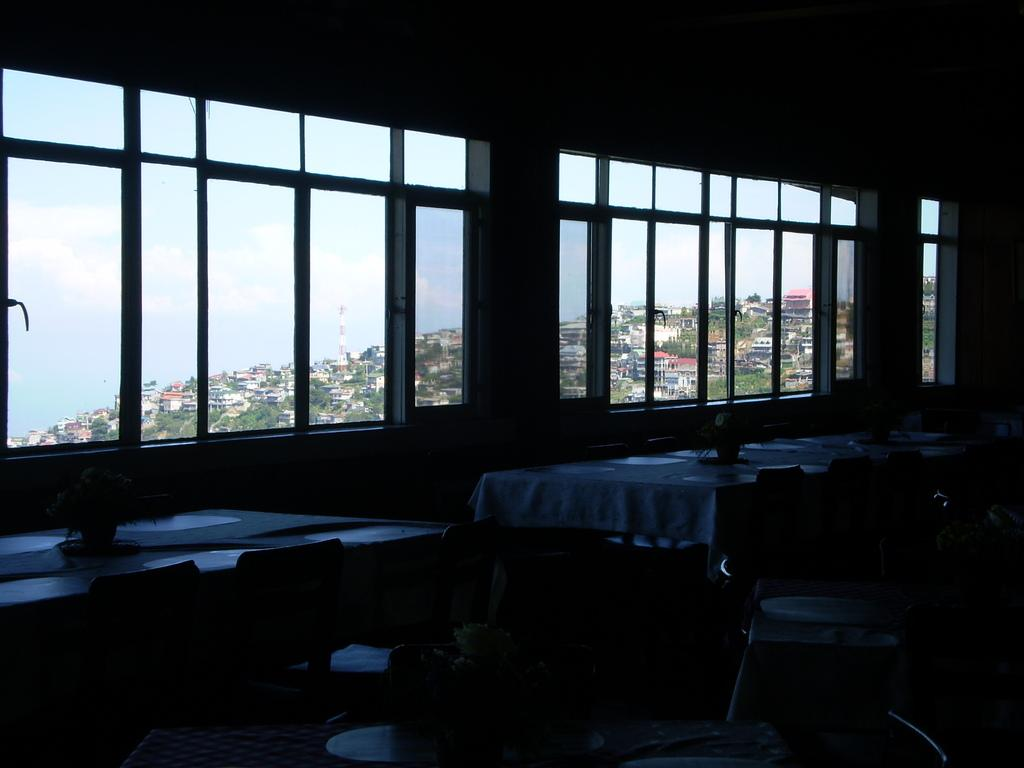What type of furniture is present in the image? There are tables and chairs in the image. What is on top of the tables in the image? There are objects on the table in the image. What architectural features can be seen in the image? There are glass windows, buildings, and trees visible in the image. What is the color of the sky in the image? The sky is blue and white in color. What type of cake is being rewarded to the person in the image? There is no cake or person present in the image, so it is not possible to answer that question. 